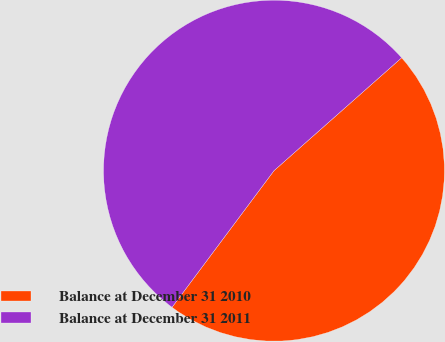Convert chart to OTSL. <chart><loc_0><loc_0><loc_500><loc_500><pie_chart><fcel>Balance at December 31 2010<fcel>Balance at December 31 2011<nl><fcel>46.73%<fcel>53.27%<nl></chart> 